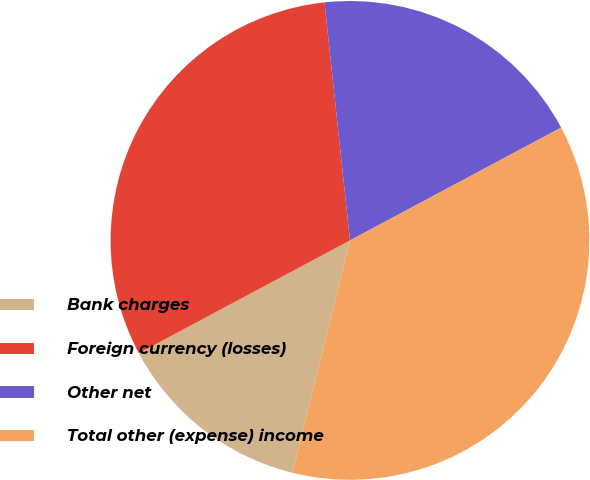Convert chart. <chart><loc_0><loc_0><loc_500><loc_500><pie_chart><fcel>Bank charges<fcel>Foreign currency (losses)<fcel>Other net<fcel>Total other (expense) income<nl><fcel>13.33%<fcel>31.11%<fcel>18.89%<fcel>36.67%<nl></chart> 